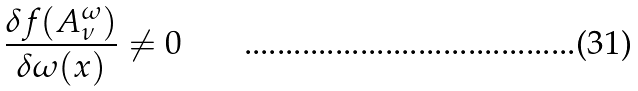Convert formula to latex. <formula><loc_0><loc_0><loc_500><loc_500>\frac { \delta f ( A ^ { \omega } _ { \nu } ) } { \delta \omega ( x ) } \neq 0</formula> 